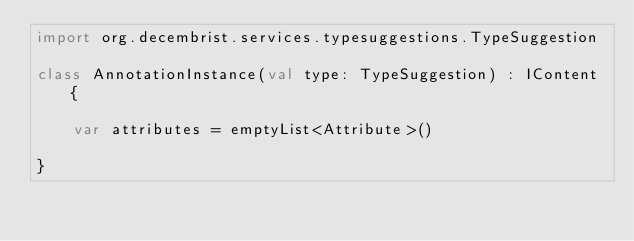<code> <loc_0><loc_0><loc_500><loc_500><_Kotlin_>import org.decembrist.services.typesuggestions.TypeSuggestion

class AnnotationInstance(val type: TypeSuggestion) : IContent {

    var attributes = emptyList<Attribute>()

}</code> 